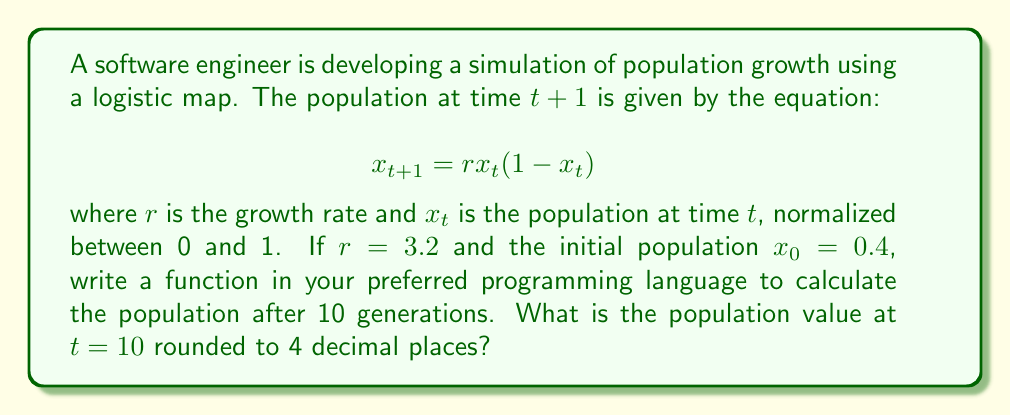Provide a solution to this math problem. To solve this problem, we need to iterate the logistic map equation for 10 generations. Here's a step-by-step approach:

1. Initialize the parameters:
   $r = 3.2$
   $x_0 = 0.4$

2. Apply the logistic map equation iteratively:
   
   For $t = 0$ to $9$:
   $$x_{t+1} = rx_t(1-x_t)$$

3. Calculate each generation:
   
   $x_1 = 3.2 * 0.4 * (1 - 0.4) = 0.768$
   $x_2 = 3.2 * 0.768 * (1 - 0.768) \approx 0.5701$
   $x_3 = 3.2 * 0.5701 * (1 - 0.5701) \approx 0.7843$
   $x_4 = 3.2 * 0.7843 * (1 - 0.7843) \approx 0.5423$
   $x_5 = 3.2 * 0.5423 * (1 - 0.5423) \approx 0.7952$
   $x_6 = 3.2 * 0.7952 * (1 - 0.7952) \approx 0.5201$
   $x_7 = 3.2 * 0.5201 * (1 - 0.5201) \approx 0.7990$
   $x_8 = 3.2 * 0.7990 * (1 - 0.7990) \approx 0.5138$
   $x_9 = 3.2 * 0.5138 * (1 - 0.5138) \approx 0.8001$
   $x_{10} = 3.2 * 0.8001 * (1 - 0.8001) \approx 0.5120$

4. Round the final result to 4 decimal places: 0.5120

A sample function in Python to calculate this would be:

```python
def logistic_map(r, x0, generations):
    x = x0
    for _ in range(generations):
        x = r * x * (1 - x)
    return round(x, 4)

result = logistic_map(3.2, 0.4, 10)
print(result)  # Output: 0.5120
```

This function is efficient and can be easily adapted to other programming languages, aligning with the persona's advocacy for using different languages for efficiency.
Answer: 0.5120 